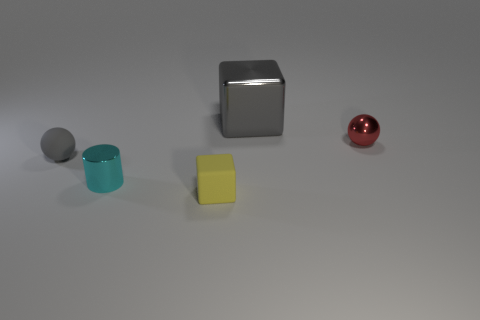What size is the ball that is the same material as the tiny block?
Your answer should be very brief. Small. What number of red objects have the same shape as the small gray object?
Keep it short and to the point. 1. Does the tiny cyan cylinder have the same material as the small sphere that is to the left of the large gray metallic thing?
Give a very brief answer. No. Is the number of shiny things behind the tiny metallic cylinder greater than the number of big gray cubes?
Your answer should be very brief. Yes. What is the shape of the other thing that is the same color as the large thing?
Offer a terse response. Sphere. Are there any cyan objects made of the same material as the yellow thing?
Make the answer very short. No. Does the tiny sphere that is on the left side of the large metal block have the same material as the block behind the red ball?
Provide a short and direct response. No. Is the number of small things that are behind the small cyan cylinder the same as the number of small red shiny objects that are behind the large gray block?
Make the answer very short. No. There is a rubber thing that is the same size as the matte sphere; what is its color?
Your response must be concise. Yellow. Is there a tiny metallic cylinder that has the same color as the shiny cube?
Provide a short and direct response. No. 